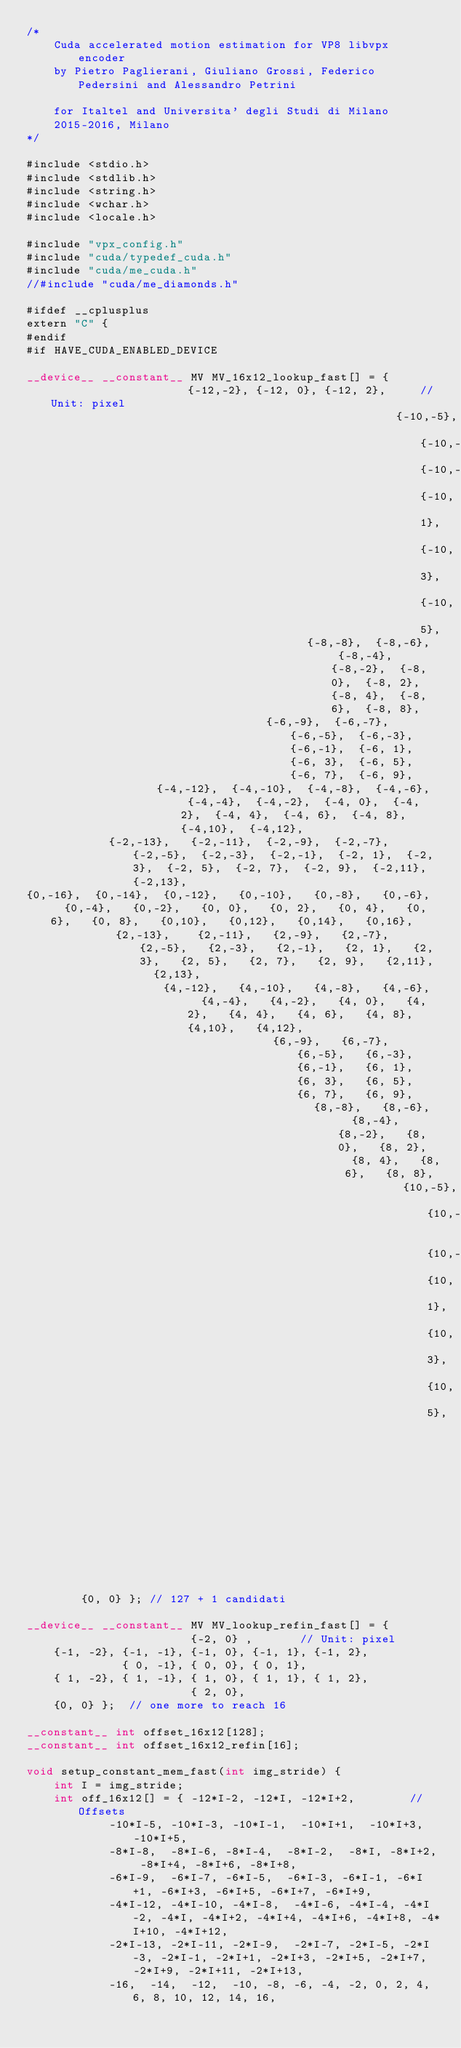Convert code to text. <code><loc_0><loc_0><loc_500><loc_500><_Cuda_>/*
    Cuda accelerated motion estimation for VP8 libvpx encoder
    by Pietro Paglierani, Giuliano Grossi, Federico Pedersini and Alessandro Petrini

    for Italtel and Universita' degli Studi di Milano
    2015-2016, Milano
*/

#include <stdio.h>
#include <stdlib.h>
#include <string.h>
#include <wchar.h>
#include <locale.h>

#include "vpx_config.h"
#include "cuda/typedef_cuda.h"
#include "cuda/me_cuda.h"
//#include "cuda/me_diamonds.h"

#ifdef __cplusplus
extern "C" {
#endif
#if HAVE_CUDA_ENABLED_DEVICE

__device__ __constant__ MV MV_16x12_lookup_fast[] = {                     {-12,-2}, {-12, 0}, {-12, 2},		// Unit: pixel
		                                              {-10,-5}, {-10,-3}, {-10,-1}, {-10, 1}, {-10, 3}, {-10, 5},
		                                 {-8,-8},  {-8,-6},  {-8,-4},  {-8,-2},  {-8, 0},  {-8, 2},  {-8, 4},  {-8, 6},  {-8, 8},
		                           {-6,-9},  {-6,-7},  {-6,-5},  {-6,-3},  {-6,-1},  {-6, 1},  {-6, 3},  {-6, 5},  {-6, 7},  {-6, 9},
		           {-4,-12},  {-4,-10},  {-4,-8},  {-4,-6},  {-4,-4},  {-4,-2},  {-4, 0},  {-4, 2},  {-4, 4},  {-4, 6},  {-4, 8},  {-4,10},  {-4,12},
	        {-2,-13},   {-2,-11},  {-2,-9},  {-2,-7},  {-2,-5},  {-2,-3},  {-2,-1},  {-2, 1},  {-2, 3},  {-2, 5},  {-2, 7},  {-2, 9},  {-2,11},  {-2,13},
{0,-16},  {0,-14},  {0,-12},   {0,-10},   {0,-8},   {0,-6},   {0,-4},   {0,-2},   {0, 0},   {0, 2},   {0, 4},   {0, 6},   {0, 8},   {0,10},   {0,12},   {0,14},   {0,16},
		     {2,-13},    {2,-11},   {2,-9},   {2,-7},   {2,-5},   {2,-3},   {2,-1},   {2, 1},   {2, 3},   {2, 5},   {2, 7},   {2, 9},   {2,11},   {2,13},
		            {4,-12},   {4,-10},   {4,-8},   {4,-6},   {4,-4},   {4,-2},   {4, 0},   {4, 2},   {4, 4},   {4, 6},   {4, 8},   {4,10},   {4,12},
		                            {6,-9},   {6,-7},   {6,-5},   {6,-3},   {6,-1},   {6, 1},   {6, 3},   {6, 5},   {6, 7},   {6, 9},
		                                  {8,-8},   {8,-6},   {8,-4},   {8,-2},   {8, 0},   {8, 2},   {8, 4},   {8, 6},   {8, 8},
		                                               {10,-5},  {10,-3},   {10,-1},  {10, 1},  {10, 3},  {10, 5},
		                                                               {12,-2},  {12, 0},  {12, 2},
		{0, 0} }; // 127 + 1 candidati

__device__ __constant__ MV MV_lookup_refin_fast[] = {
	                    {-2, 0} ,		// Unit: pixel
	{-1, -2}, {-1, -1}, {-1, 0}, {-1, 1}, {-1, 2},
	          { 0, -1}, { 0, 0}, { 0, 1},
	{ 1, -2}, { 1, -1}, { 1, 0}, { 1, 1}, { 1, 2},
	                    { 2, 0},
	{0, 0} };  // one more to reach 16

__constant__ int offset_16x12[128];
__constant__ int offset_16x12_refin[16];

void setup_constant_mem_fast(int img_stride) {
	int I = img_stride;
	int off_16x12[] = { -12*I-2, -12*I, -12*I+2,		// Offsets
			-10*I-5, -10*I-3, -10*I-1,  -10*I+1,  -10*I+3, -10*I+5,
			-8*I-8,  -8*I-6, -8*I-4,  -8*I-2,  -8*I, -8*I+2, -8*I+4, -8*I+6, -8*I+8,
			-6*I-9,  -6*I-7, -6*I-5,  -6*I-3, -6*I-1, -6*I+1, -6*I+3, -6*I+5, -6*I+7, -6*I+9,
			-4*I-12, -4*I-10, -4*I-8,  -4*I-6, -4*I-4, -4*I-2, -4*I, -4*I+2, -4*I+4, -4*I+6, -4*I+8, -4*I+10, -4*I+12,
			-2*I-13, -2*I-11, -2*I-9,  -2*I-7, -2*I-5, -2*I-3, -2*I-1, -2*I+1, -2*I+3, -2*I+5, -2*I+7, -2*I+9, -2*I+11, -2*I+13,
			-16,  -14,  -12,  -10, -8, -6, -4, -2, 0, 2, 4, 6, 8, 10, 12, 14, 16,</code> 